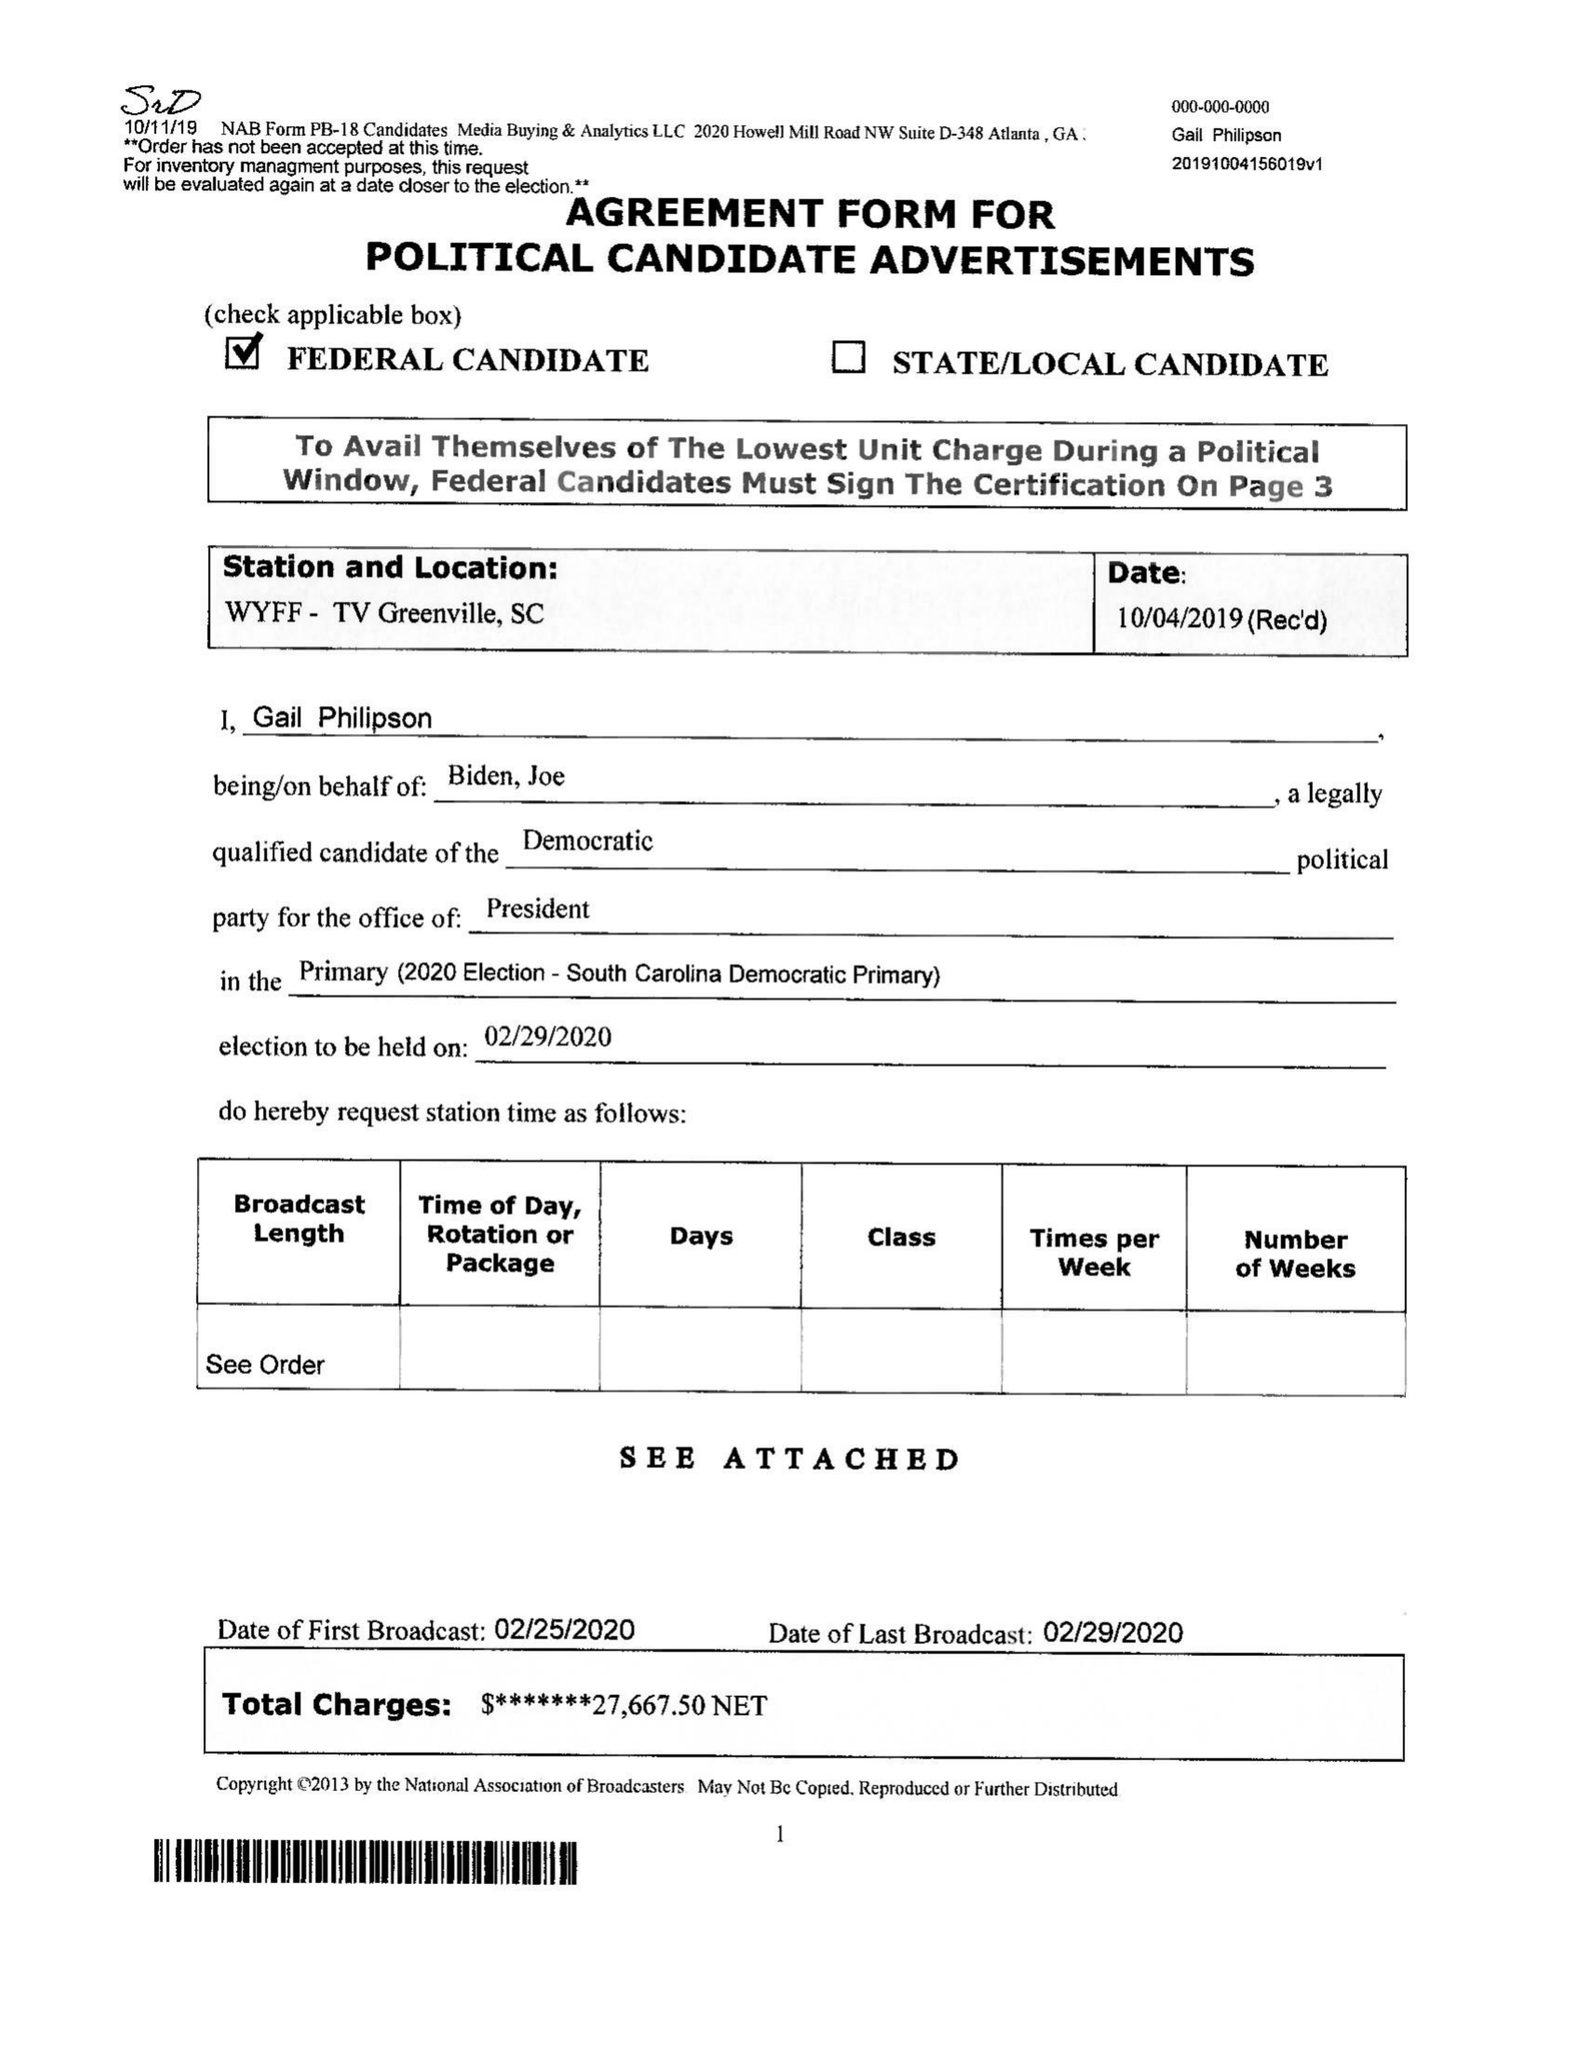What is the value for the contract_num?
Answer the question using a single word or phrase. None 